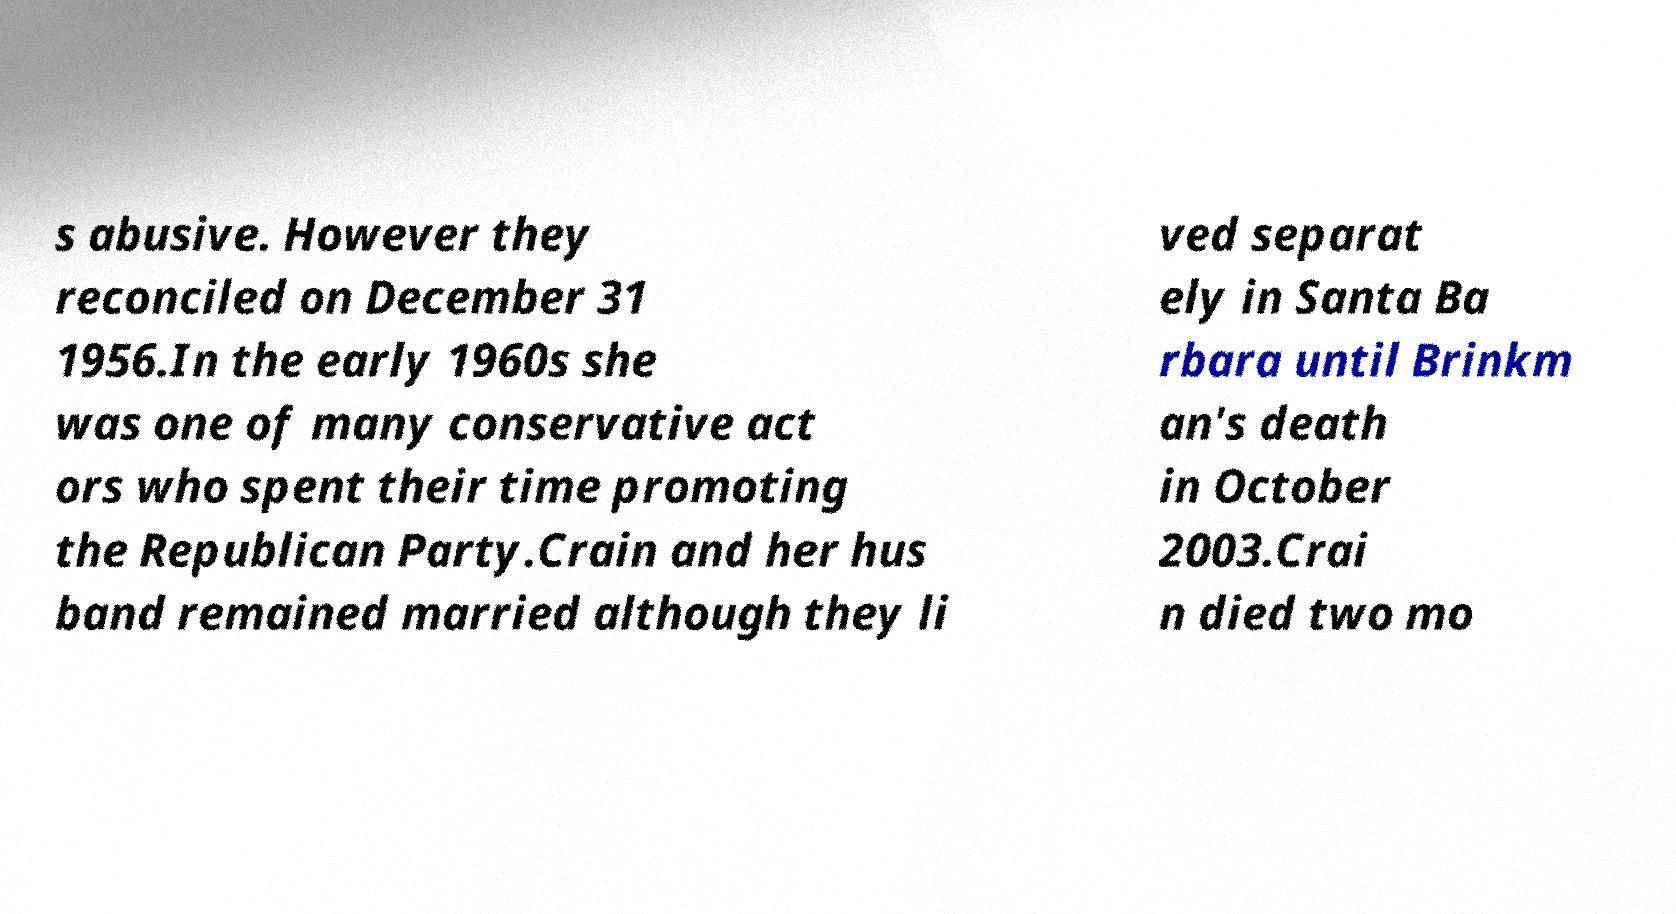Please identify and transcribe the text found in this image. s abusive. However they reconciled on December 31 1956.In the early 1960s she was one of many conservative act ors who spent their time promoting the Republican Party.Crain and her hus band remained married although they li ved separat ely in Santa Ba rbara until Brinkm an's death in October 2003.Crai n died two mo 